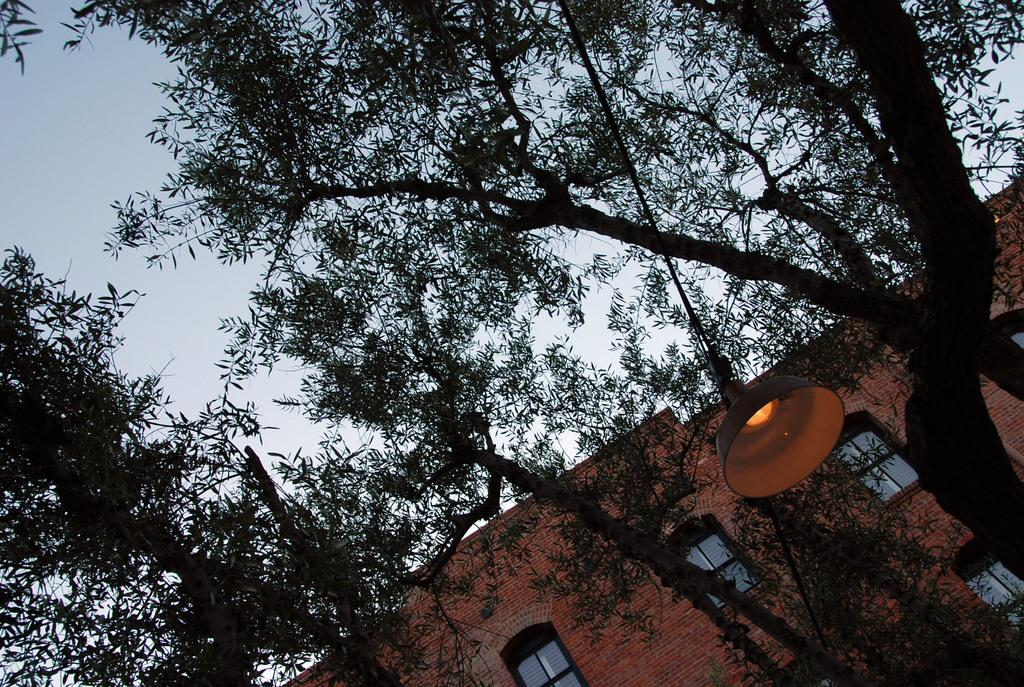What type of vegetation is in the foreground area of the image? There are trees in the foreground area of the image. What object can be seen in the image that provides light? There is a lamp in the image. Where is the rope located in the image? The rope is on the right side of the image. What can be seen in the background area of the image? There is a building and the sky visible in the background area of the image. How many rabbits are hopping in the image? There are no rabbits present in the image. What season is depicted in the image based on the presence of spring flowers? There is no mention of spring flowers or any seasonal indicators in the image. 